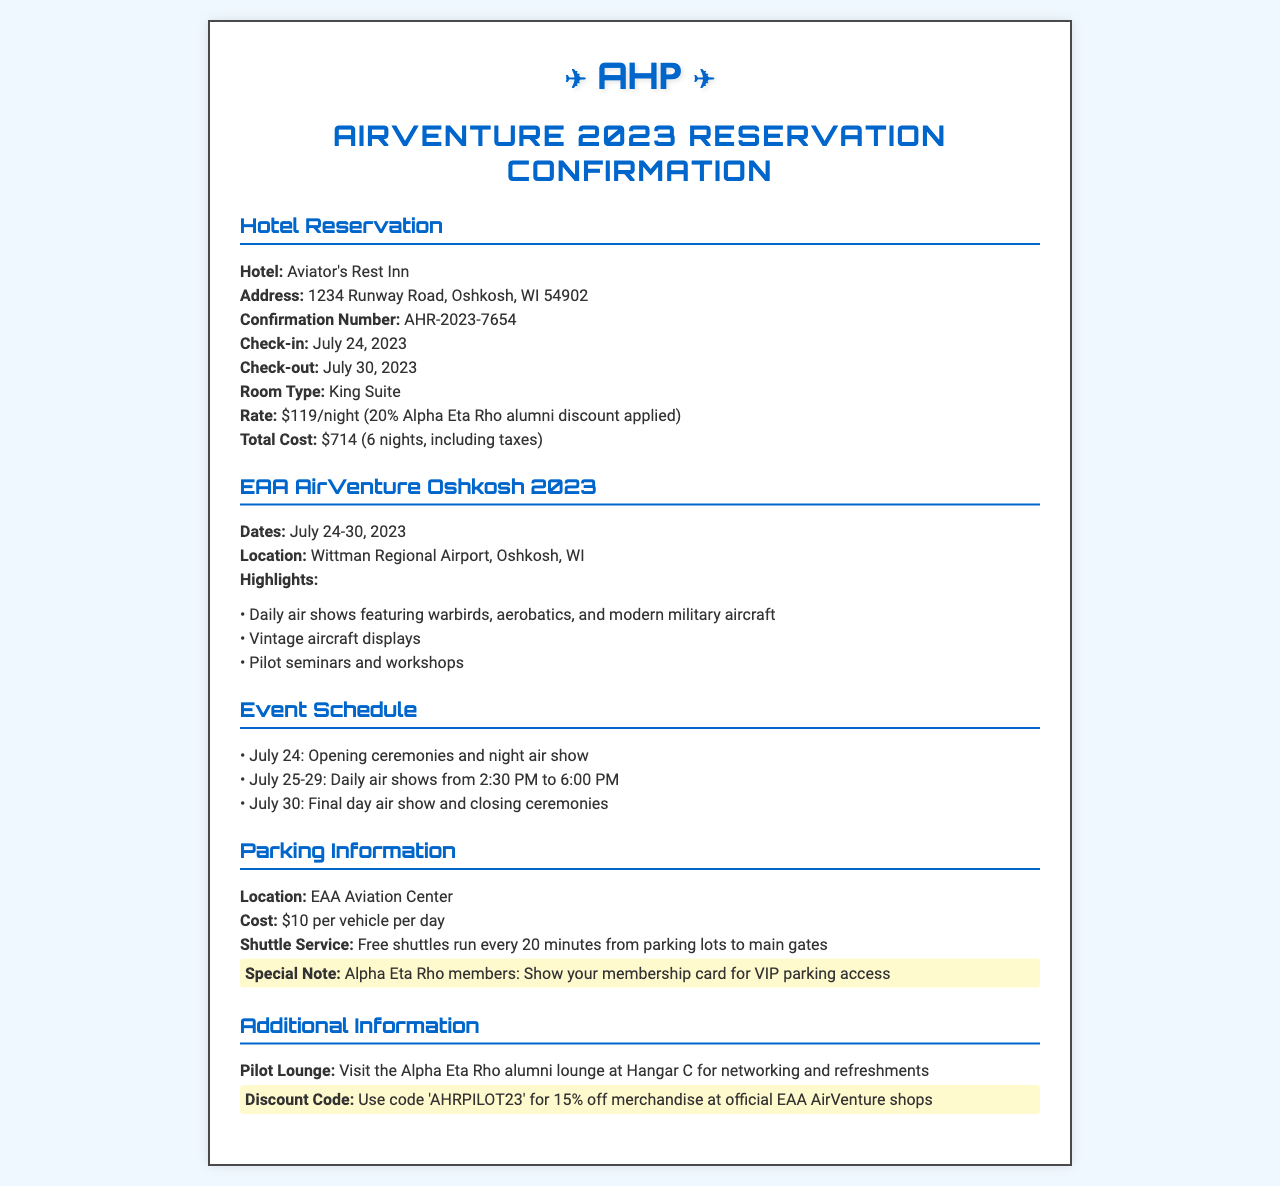What is the name of the hotel? The name of the hotel provided in the document is Aviator's Rest Inn.
Answer: Aviator's Rest Inn What is the confirmation number? The document states the confirmation number is AHR-2023-7654.
Answer: AHR-2023-7654 What is the total cost of the stay? The total cost listed in the document for the stay is $714, including taxes.
Answer: $714 When is the check-in date? The check-in date mentioned in the document is July 24, 2023.
Answer: July 24, 2023 What is the parking cost per vehicle per day? The document specifies that the parking cost is $10 per vehicle per day.
Answer: $10 On which date do the daily air shows start? The daily air shows start on July 25 according to the event schedule in the document.
Answer: July 25 What discount is given for Alpha Eta Rho alumni? The document mentions a 20% discount applied for Alpha Eta Rho alumni.
Answer: 20% What is the location of the parking? The parking location provided in the document is EAA Aviation Center.
Answer: EAA Aviation Center What special note is mentioned for Alpha Eta Rho members? The document highlights that Alpha Eta Rho members can show their membership card for VIP parking access.
Answer: VIP parking access 